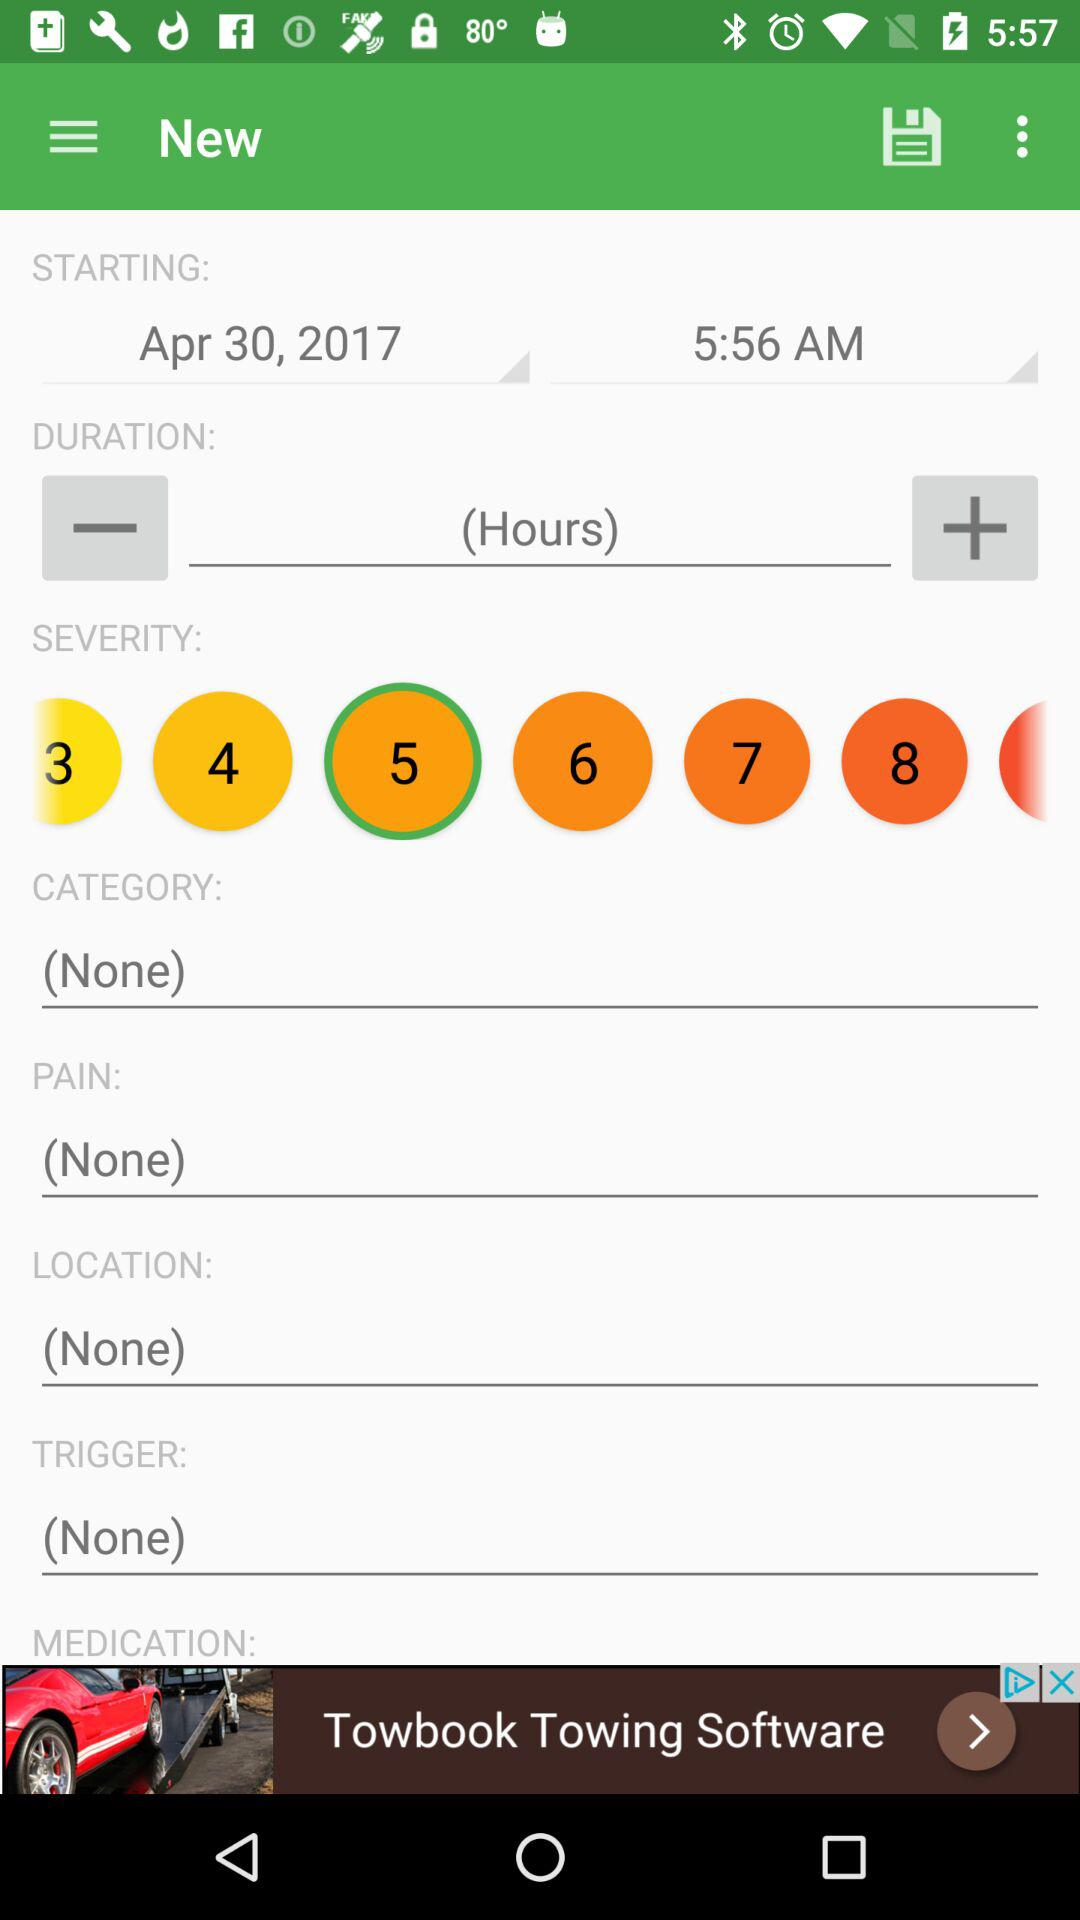What unit is duration in? Duration is in hours. 